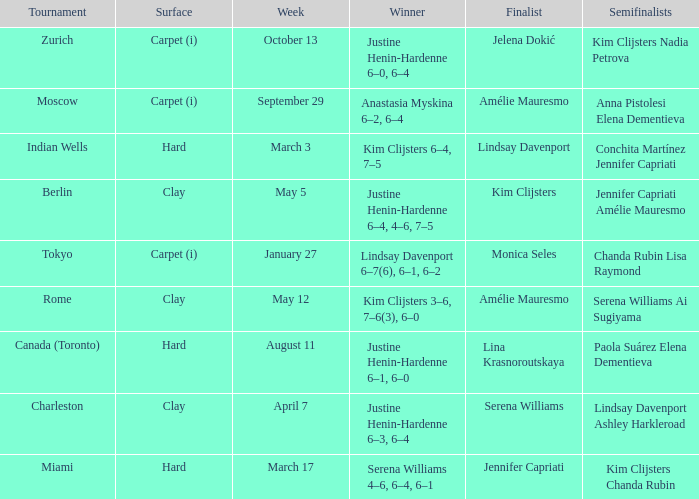Who was the winner against finalist Lina Krasnoroutskaya? Justine Henin-Hardenne 6–1, 6–0. 